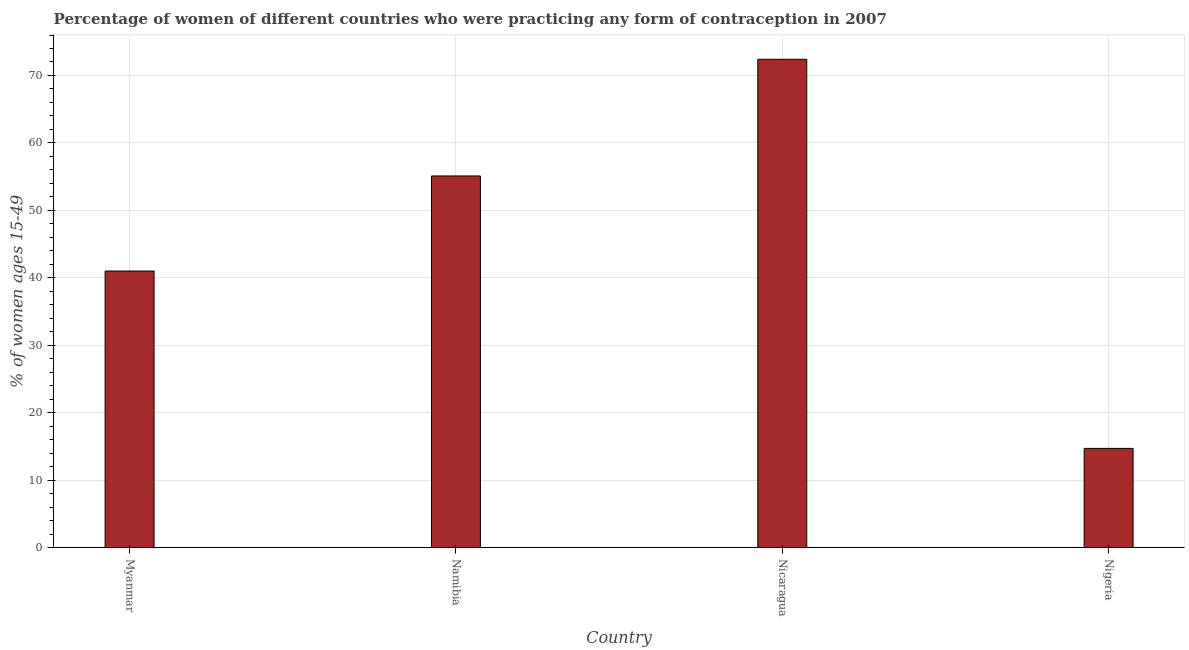Does the graph contain any zero values?
Your answer should be compact. No. What is the title of the graph?
Offer a terse response. Percentage of women of different countries who were practicing any form of contraception in 2007. What is the label or title of the Y-axis?
Ensure brevity in your answer.  % of women ages 15-49. What is the contraceptive prevalence in Nicaragua?
Give a very brief answer. 72.4. Across all countries, what is the maximum contraceptive prevalence?
Ensure brevity in your answer.  72.4. In which country was the contraceptive prevalence maximum?
Make the answer very short. Nicaragua. In which country was the contraceptive prevalence minimum?
Your answer should be very brief. Nigeria. What is the sum of the contraceptive prevalence?
Your answer should be very brief. 183.2. What is the difference between the contraceptive prevalence in Namibia and Nicaragua?
Give a very brief answer. -17.3. What is the average contraceptive prevalence per country?
Your answer should be compact. 45.8. What is the median contraceptive prevalence?
Ensure brevity in your answer.  48.05. What is the ratio of the contraceptive prevalence in Myanmar to that in Namibia?
Offer a very short reply. 0.74. Is the contraceptive prevalence in Myanmar less than that in Nigeria?
Provide a short and direct response. No. Is the difference between the contraceptive prevalence in Namibia and Nicaragua greater than the difference between any two countries?
Your answer should be very brief. No. What is the difference between the highest and the lowest contraceptive prevalence?
Provide a short and direct response. 57.7. How many bars are there?
Your response must be concise. 4. Are all the bars in the graph horizontal?
Provide a succinct answer. No. What is the % of women ages 15-49 of Namibia?
Make the answer very short. 55.1. What is the % of women ages 15-49 in Nicaragua?
Provide a short and direct response. 72.4. What is the difference between the % of women ages 15-49 in Myanmar and Namibia?
Make the answer very short. -14.1. What is the difference between the % of women ages 15-49 in Myanmar and Nicaragua?
Ensure brevity in your answer.  -31.4. What is the difference between the % of women ages 15-49 in Myanmar and Nigeria?
Ensure brevity in your answer.  26.3. What is the difference between the % of women ages 15-49 in Namibia and Nicaragua?
Your response must be concise. -17.3. What is the difference between the % of women ages 15-49 in Namibia and Nigeria?
Keep it short and to the point. 40.4. What is the difference between the % of women ages 15-49 in Nicaragua and Nigeria?
Ensure brevity in your answer.  57.7. What is the ratio of the % of women ages 15-49 in Myanmar to that in Namibia?
Provide a short and direct response. 0.74. What is the ratio of the % of women ages 15-49 in Myanmar to that in Nicaragua?
Make the answer very short. 0.57. What is the ratio of the % of women ages 15-49 in Myanmar to that in Nigeria?
Give a very brief answer. 2.79. What is the ratio of the % of women ages 15-49 in Namibia to that in Nicaragua?
Provide a succinct answer. 0.76. What is the ratio of the % of women ages 15-49 in Namibia to that in Nigeria?
Make the answer very short. 3.75. What is the ratio of the % of women ages 15-49 in Nicaragua to that in Nigeria?
Your answer should be very brief. 4.92. 